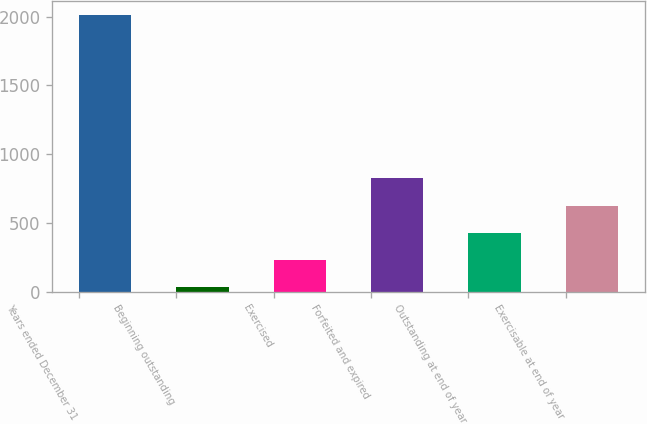<chart> <loc_0><loc_0><loc_500><loc_500><bar_chart><fcel>Years ended December 31<fcel>Beginning outstanding<fcel>Exercised<fcel>Forfeited and expired<fcel>Outstanding at end of year<fcel>Exercisable at end of year<nl><fcel>2013<fcel>32<fcel>230.1<fcel>824.4<fcel>428.2<fcel>626.3<nl></chart> 